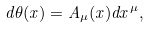Convert formula to latex. <formula><loc_0><loc_0><loc_500><loc_500>d \theta ( x ) = A _ { \mu } ( x ) d x ^ { \mu } ,</formula> 